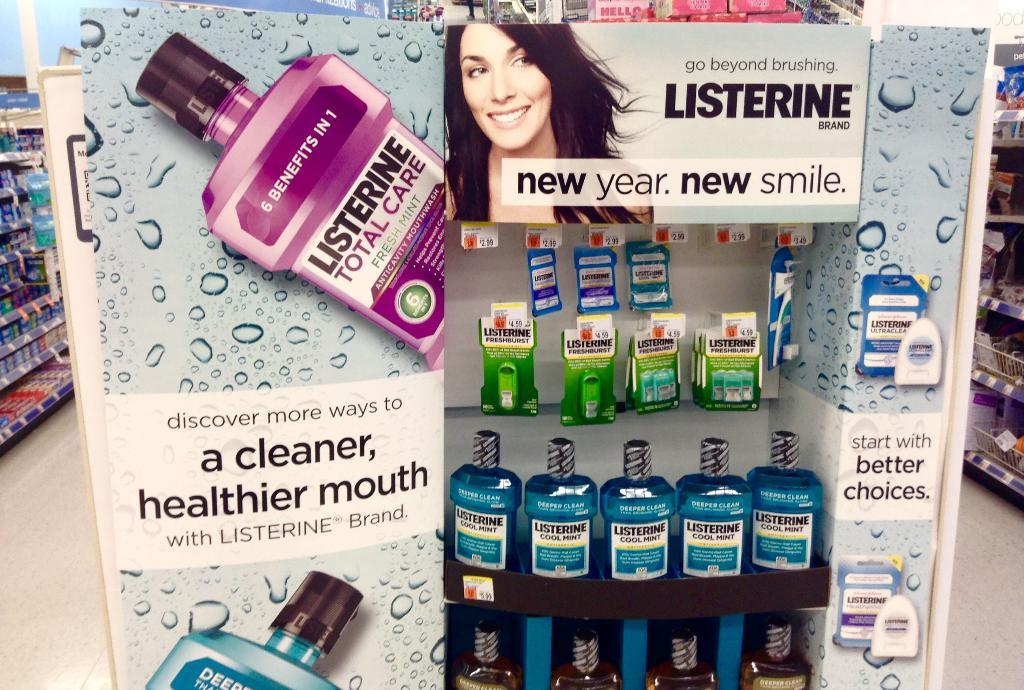Provide a one-sentence caption for the provided image. A row of Listerine bottles on a display shelf in a store. 